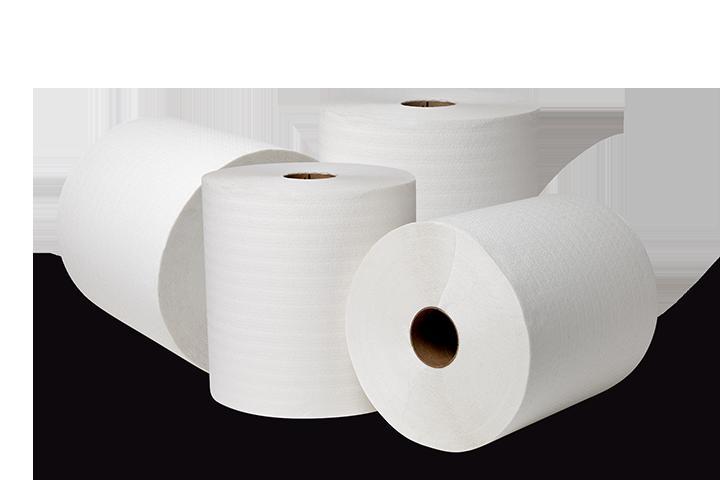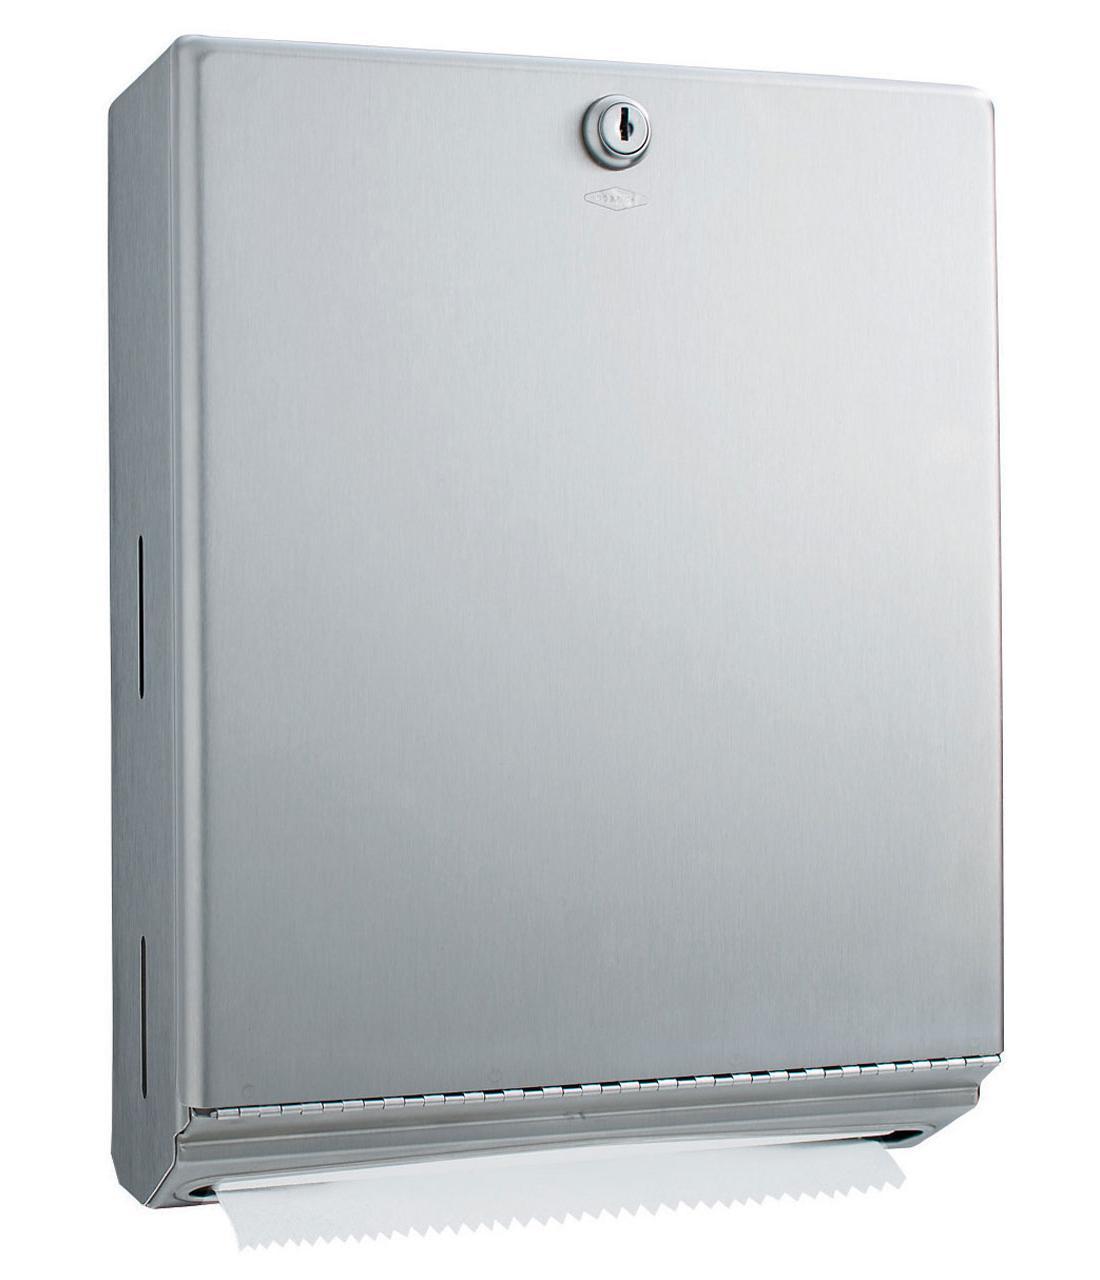The first image is the image on the left, the second image is the image on the right. For the images shown, is this caption "Both images show white paper towels on rolls." true? Answer yes or no. No. The first image is the image on the left, the second image is the image on the right. Analyze the images presented: Is the assertion "An image shows exactly one roll standing next to one roll on its side." valid? Answer yes or no. No. 